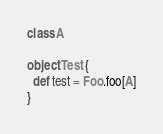Convert code to text. <code><loc_0><loc_0><loc_500><loc_500><_Scala_>class A

object Test {
  def test = Foo.foo[A]
}
</code> 